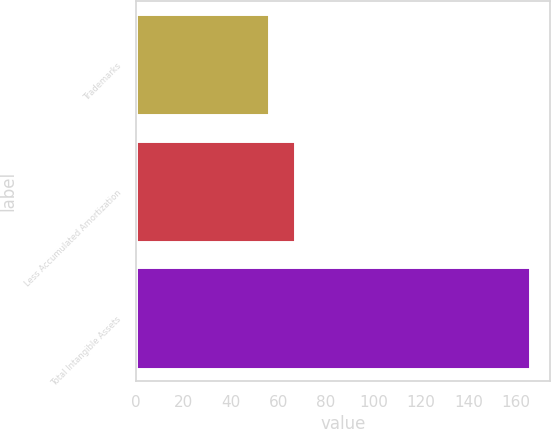Convert chart to OTSL. <chart><loc_0><loc_0><loc_500><loc_500><bar_chart><fcel>Trademarks<fcel>Less Accumulated Amortization<fcel>Total Intangible Assets<nl><fcel>56<fcel>67<fcel>166<nl></chart> 